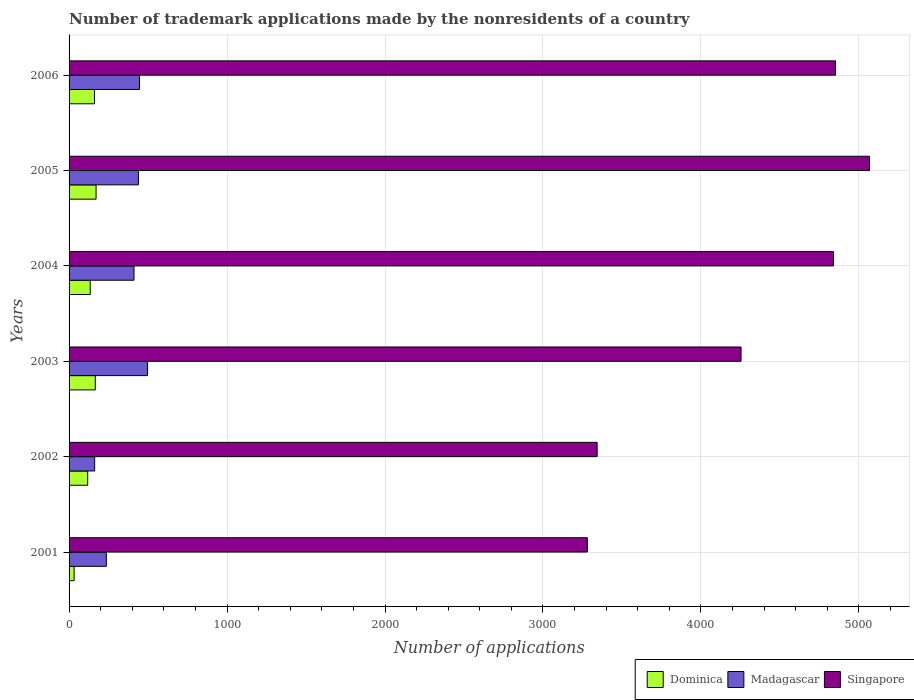Are the number of bars per tick equal to the number of legend labels?
Give a very brief answer. Yes. Are the number of bars on each tick of the Y-axis equal?
Offer a terse response. Yes. How many bars are there on the 6th tick from the bottom?
Make the answer very short. 3. What is the label of the 1st group of bars from the top?
Give a very brief answer. 2006. In how many cases, is the number of bars for a given year not equal to the number of legend labels?
Offer a very short reply. 0. What is the number of trademark applications made by the nonresidents in Singapore in 2004?
Keep it short and to the point. 4839. Across all years, what is the maximum number of trademark applications made by the nonresidents in Singapore?
Offer a terse response. 5067. Across all years, what is the minimum number of trademark applications made by the nonresidents in Madagascar?
Ensure brevity in your answer.  162. What is the total number of trademark applications made by the nonresidents in Madagascar in the graph?
Ensure brevity in your answer.  2191. What is the difference between the number of trademark applications made by the nonresidents in Madagascar in 2002 and that in 2005?
Your answer should be compact. -277. What is the difference between the number of trademark applications made by the nonresidents in Madagascar in 2006 and the number of trademark applications made by the nonresidents in Singapore in 2003?
Provide a short and direct response. -3808. What is the average number of trademark applications made by the nonresidents in Singapore per year?
Offer a very short reply. 4272.67. In the year 2005, what is the difference between the number of trademark applications made by the nonresidents in Dominica and number of trademark applications made by the nonresidents in Madagascar?
Your answer should be compact. -268. What is the ratio of the number of trademark applications made by the nonresidents in Dominica in 2002 to that in 2006?
Ensure brevity in your answer.  0.73. Is the difference between the number of trademark applications made by the nonresidents in Dominica in 2002 and 2003 greater than the difference between the number of trademark applications made by the nonresidents in Madagascar in 2002 and 2003?
Your answer should be compact. Yes. What is the difference between the highest and the lowest number of trademark applications made by the nonresidents in Madagascar?
Make the answer very short. 335. Is the sum of the number of trademark applications made by the nonresidents in Dominica in 2003 and 2006 greater than the maximum number of trademark applications made by the nonresidents in Madagascar across all years?
Provide a short and direct response. No. What does the 3rd bar from the top in 2002 represents?
Your answer should be very brief. Dominica. What does the 1st bar from the bottom in 2006 represents?
Your answer should be very brief. Dominica. Is it the case that in every year, the sum of the number of trademark applications made by the nonresidents in Madagascar and number of trademark applications made by the nonresidents in Dominica is greater than the number of trademark applications made by the nonresidents in Singapore?
Offer a very short reply. No. How many bars are there?
Your answer should be compact. 18. Are all the bars in the graph horizontal?
Offer a very short reply. Yes. Are the values on the major ticks of X-axis written in scientific E-notation?
Make the answer very short. No. Does the graph contain grids?
Give a very brief answer. Yes. Where does the legend appear in the graph?
Keep it short and to the point. Bottom right. How many legend labels are there?
Make the answer very short. 3. How are the legend labels stacked?
Keep it short and to the point. Horizontal. What is the title of the graph?
Keep it short and to the point. Number of trademark applications made by the nonresidents of a country. What is the label or title of the X-axis?
Keep it short and to the point. Number of applications. What is the label or title of the Y-axis?
Offer a terse response. Years. What is the Number of applications of Madagascar in 2001?
Your response must be concise. 236. What is the Number of applications in Singapore in 2001?
Offer a terse response. 3281. What is the Number of applications of Dominica in 2002?
Your answer should be very brief. 118. What is the Number of applications of Madagascar in 2002?
Your answer should be very brief. 162. What is the Number of applications in Singapore in 2002?
Your answer should be very brief. 3343. What is the Number of applications of Dominica in 2003?
Your answer should be compact. 166. What is the Number of applications of Madagascar in 2003?
Offer a very short reply. 497. What is the Number of applications of Singapore in 2003?
Your answer should be very brief. 4254. What is the Number of applications in Dominica in 2004?
Offer a terse response. 134. What is the Number of applications in Madagascar in 2004?
Offer a terse response. 411. What is the Number of applications in Singapore in 2004?
Offer a very short reply. 4839. What is the Number of applications of Dominica in 2005?
Offer a very short reply. 171. What is the Number of applications in Madagascar in 2005?
Your response must be concise. 439. What is the Number of applications in Singapore in 2005?
Provide a succinct answer. 5067. What is the Number of applications in Dominica in 2006?
Offer a terse response. 161. What is the Number of applications of Madagascar in 2006?
Offer a terse response. 446. What is the Number of applications in Singapore in 2006?
Offer a very short reply. 4852. Across all years, what is the maximum Number of applications of Dominica?
Your answer should be very brief. 171. Across all years, what is the maximum Number of applications in Madagascar?
Make the answer very short. 497. Across all years, what is the maximum Number of applications of Singapore?
Give a very brief answer. 5067. Across all years, what is the minimum Number of applications in Dominica?
Give a very brief answer. 32. Across all years, what is the minimum Number of applications of Madagascar?
Keep it short and to the point. 162. Across all years, what is the minimum Number of applications in Singapore?
Ensure brevity in your answer.  3281. What is the total Number of applications of Dominica in the graph?
Give a very brief answer. 782. What is the total Number of applications in Madagascar in the graph?
Give a very brief answer. 2191. What is the total Number of applications of Singapore in the graph?
Offer a terse response. 2.56e+04. What is the difference between the Number of applications in Dominica in 2001 and that in 2002?
Your answer should be very brief. -86. What is the difference between the Number of applications in Singapore in 2001 and that in 2002?
Your answer should be very brief. -62. What is the difference between the Number of applications of Dominica in 2001 and that in 2003?
Your answer should be compact. -134. What is the difference between the Number of applications of Madagascar in 2001 and that in 2003?
Keep it short and to the point. -261. What is the difference between the Number of applications of Singapore in 2001 and that in 2003?
Your answer should be compact. -973. What is the difference between the Number of applications of Dominica in 2001 and that in 2004?
Provide a short and direct response. -102. What is the difference between the Number of applications of Madagascar in 2001 and that in 2004?
Your answer should be very brief. -175. What is the difference between the Number of applications in Singapore in 2001 and that in 2004?
Offer a very short reply. -1558. What is the difference between the Number of applications in Dominica in 2001 and that in 2005?
Ensure brevity in your answer.  -139. What is the difference between the Number of applications of Madagascar in 2001 and that in 2005?
Keep it short and to the point. -203. What is the difference between the Number of applications of Singapore in 2001 and that in 2005?
Make the answer very short. -1786. What is the difference between the Number of applications of Dominica in 2001 and that in 2006?
Make the answer very short. -129. What is the difference between the Number of applications of Madagascar in 2001 and that in 2006?
Your response must be concise. -210. What is the difference between the Number of applications of Singapore in 2001 and that in 2006?
Your answer should be compact. -1571. What is the difference between the Number of applications of Dominica in 2002 and that in 2003?
Offer a very short reply. -48. What is the difference between the Number of applications of Madagascar in 2002 and that in 2003?
Offer a terse response. -335. What is the difference between the Number of applications of Singapore in 2002 and that in 2003?
Your answer should be compact. -911. What is the difference between the Number of applications in Madagascar in 2002 and that in 2004?
Give a very brief answer. -249. What is the difference between the Number of applications in Singapore in 2002 and that in 2004?
Keep it short and to the point. -1496. What is the difference between the Number of applications in Dominica in 2002 and that in 2005?
Your response must be concise. -53. What is the difference between the Number of applications of Madagascar in 2002 and that in 2005?
Give a very brief answer. -277. What is the difference between the Number of applications of Singapore in 2002 and that in 2005?
Ensure brevity in your answer.  -1724. What is the difference between the Number of applications in Dominica in 2002 and that in 2006?
Give a very brief answer. -43. What is the difference between the Number of applications of Madagascar in 2002 and that in 2006?
Your answer should be very brief. -284. What is the difference between the Number of applications in Singapore in 2002 and that in 2006?
Give a very brief answer. -1509. What is the difference between the Number of applications of Singapore in 2003 and that in 2004?
Make the answer very short. -585. What is the difference between the Number of applications of Dominica in 2003 and that in 2005?
Keep it short and to the point. -5. What is the difference between the Number of applications of Singapore in 2003 and that in 2005?
Provide a short and direct response. -813. What is the difference between the Number of applications in Madagascar in 2003 and that in 2006?
Provide a succinct answer. 51. What is the difference between the Number of applications in Singapore in 2003 and that in 2006?
Provide a short and direct response. -598. What is the difference between the Number of applications in Dominica in 2004 and that in 2005?
Provide a short and direct response. -37. What is the difference between the Number of applications of Madagascar in 2004 and that in 2005?
Keep it short and to the point. -28. What is the difference between the Number of applications of Singapore in 2004 and that in 2005?
Provide a succinct answer. -228. What is the difference between the Number of applications in Dominica in 2004 and that in 2006?
Keep it short and to the point. -27. What is the difference between the Number of applications of Madagascar in 2004 and that in 2006?
Provide a short and direct response. -35. What is the difference between the Number of applications of Dominica in 2005 and that in 2006?
Offer a very short reply. 10. What is the difference between the Number of applications of Singapore in 2005 and that in 2006?
Provide a short and direct response. 215. What is the difference between the Number of applications of Dominica in 2001 and the Number of applications of Madagascar in 2002?
Offer a terse response. -130. What is the difference between the Number of applications of Dominica in 2001 and the Number of applications of Singapore in 2002?
Your answer should be compact. -3311. What is the difference between the Number of applications in Madagascar in 2001 and the Number of applications in Singapore in 2002?
Offer a terse response. -3107. What is the difference between the Number of applications of Dominica in 2001 and the Number of applications of Madagascar in 2003?
Your response must be concise. -465. What is the difference between the Number of applications of Dominica in 2001 and the Number of applications of Singapore in 2003?
Offer a very short reply. -4222. What is the difference between the Number of applications of Madagascar in 2001 and the Number of applications of Singapore in 2003?
Offer a very short reply. -4018. What is the difference between the Number of applications of Dominica in 2001 and the Number of applications of Madagascar in 2004?
Make the answer very short. -379. What is the difference between the Number of applications in Dominica in 2001 and the Number of applications in Singapore in 2004?
Ensure brevity in your answer.  -4807. What is the difference between the Number of applications in Madagascar in 2001 and the Number of applications in Singapore in 2004?
Make the answer very short. -4603. What is the difference between the Number of applications in Dominica in 2001 and the Number of applications in Madagascar in 2005?
Make the answer very short. -407. What is the difference between the Number of applications of Dominica in 2001 and the Number of applications of Singapore in 2005?
Give a very brief answer. -5035. What is the difference between the Number of applications in Madagascar in 2001 and the Number of applications in Singapore in 2005?
Your answer should be compact. -4831. What is the difference between the Number of applications of Dominica in 2001 and the Number of applications of Madagascar in 2006?
Ensure brevity in your answer.  -414. What is the difference between the Number of applications in Dominica in 2001 and the Number of applications in Singapore in 2006?
Your answer should be compact. -4820. What is the difference between the Number of applications of Madagascar in 2001 and the Number of applications of Singapore in 2006?
Offer a terse response. -4616. What is the difference between the Number of applications of Dominica in 2002 and the Number of applications of Madagascar in 2003?
Make the answer very short. -379. What is the difference between the Number of applications in Dominica in 2002 and the Number of applications in Singapore in 2003?
Offer a terse response. -4136. What is the difference between the Number of applications of Madagascar in 2002 and the Number of applications of Singapore in 2003?
Make the answer very short. -4092. What is the difference between the Number of applications in Dominica in 2002 and the Number of applications in Madagascar in 2004?
Your answer should be very brief. -293. What is the difference between the Number of applications in Dominica in 2002 and the Number of applications in Singapore in 2004?
Your response must be concise. -4721. What is the difference between the Number of applications in Madagascar in 2002 and the Number of applications in Singapore in 2004?
Keep it short and to the point. -4677. What is the difference between the Number of applications of Dominica in 2002 and the Number of applications of Madagascar in 2005?
Offer a terse response. -321. What is the difference between the Number of applications in Dominica in 2002 and the Number of applications in Singapore in 2005?
Provide a short and direct response. -4949. What is the difference between the Number of applications of Madagascar in 2002 and the Number of applications of Singapore in 2005?
Offer a very short reply. -4905. What is the difference between the Number of applications in Dominica in 2002 and the Number of applications in Madagascar in 2006?
Keep it short and to the point. -328. What is the difference between the Number of applications of Dominica in 2002 and the Number of applications of Singapore in 2006?
Give a very brief answer. -4734. What is the difference between the Number of applications of Madagascar in 2002 and the Number of applications of Singapore in 2006?
Ensure brevity in your answer.  -4690. What is the difference between the Number of applications in Dominica in 2003 and the Number of applications in Madagascar in 2004?
Provide a succinct answer. -245. What is the difference between the Number of applications of Dominica in 2003 and the Number of applications of Singapore in 2004?
Provide a short and direct response. -4673. What is the difference between the Number of applications in Madagascar in 2003 and the Number of applications in Singapore in 2004?
Provide a succinct answer. -4342. What is the difference between the Number of applications in Dominica in 2003 and the Number of applications in Madagascar in 2005?
Offer a very short reply. -273. What is the difference between the Number of applications of Dominica in 2003 and the Number of applications of Singapore in 2005?
Ensure brevity in your answer.  -4901. What is the difference between the Number of applications of Madagascar in 2003 and the Number of applications of Singapore in 2005?
Offer a terse response. -4570. What is the difference between the Number of applications in Dominica in 2003 and the Number of applications in Madagascar in 2006?
Provide a short and direct response. -280. What is the difference between the Number of applications in Dominica in 2003 and the Number of applications in Singapore in 2006?
Provide a succinct answer. -4686. What is the difference between the Number of applications in Madagascar in 2003 and the Number of applications in Singapore in 2006?
Offer a terse response. -4355. What is the difference between the Number of applications in Dominica in 2004 and the Number of applications in Madagascar in 2005?
Offer a very short reply. -305. What is the difference between the Number of applications of Dominica in 2004 and the Number of applications of Singapore in 2005?
Offer a very short reply. -4933. What is the difference between the Number of applications in Madagascar in 2004 and the Number of applications in Singapore in 2005?
Your answer should be compact. -4656. What is the difference between the Number of applications of Dominica in 2004 and the Number of applications of Madagascar in 2006?
Offer a terse response. -312. What is the difference between the Number of applications in Dominica in 2004 and the Number of applications in Singapore in 2006?
Keep it short and to the point. -4718. What is the difference between the Number of applications in Madagascar in 2004 and the Number of applications in Singapore in 2006?
Offer a very short reply. -4441. What is the difference between the Number of applications of Dominica in 2005 and the Number of applications of Madagascar in 2006?
Offer a terse response. -275. What is the difference between the Number of applications in Dominica in 2005 and the Number of applications in Singapore in 2006?
Your response must be concise. -4681. What is the difference between the Number of applications in Madagascar in 2005 and the Number of applications in Singapore in 2006?
Your response must be concise. -4413. What is the average Number of applications in Dominica per year?
Your answer should be compact. 130.33. What is the average Number of applications of Madagascar per year?
Your answer should be very brief. 365.17. What is the average Number of applications of Singapore per year?
Provide a short and direct response. 4272.67. In the year 2001, what is the difference between the Number of applications of Dominica and Number of applications of Madagascar?
Give a very brief answer. -204. In the year 2001, what is the difference between the Number of applications in Dominica and Number of applications in Singapore?
Your response must be concise. -3249. In the year 2001, what is the difference between the Number of applications of Madagascar and Number of applications of Singapore?
Offer a very short reply. -3045. In the year 2002, what is the difference between the Number of applications in Dominica and Number of applications in Madagascar?
Offer a terse response. -44. In the year 2002, what is the difference between the Number of applications of Dominica and Number of applications of Singapore?
Your response must be concise. -3225. In the year 2002, what is the difference between the Number of applications of Madagascar and Number of applications of Singapore?
Make the answer very short. -3181. In the year 2003, what is the difference between the Number of applications of Dominica and Number of applications of Madagascar?
Provide a succinct answer. -331. In the year 2003, what is the difference between the Number of applications in Dominica and Number of applications in Singapore?
Keep it short and to the point. -4088. In the year 2003, what is the difference between the Number of applications of Madagascar and Number of applications of Singapore?
Provide a succinct answer. -3757. In the year 2004, what is the difference between the Number of applications of Dominica and Number of applications of Madagascar?
Offer a very short reply. -277. In the year 2004, what is the difference between the Number of applications of Dominica and Number of applications of Singapore?
Offer a very short reply. -4705. In the year 2004, what is the difference between the Number of applications of Madagascar and Number of applications of Singapore?
Your answer should be very brief. -4428. In the year 2005, what is the difference between the Number of applications in Dominica and Number of applications in Madagascar?
Ensure brevity in your answer.  -268. In the year 2005, what is the difference between the Number of applications in Dominica and Number of applications in Singapore?
Provide a short and direct response. -4896. In the year 2005, what is the difference between the Number of applications in Madagascar and Number of applications in Singapore?
Provide a succinct answer. -4628. In the year 2006, what is the difference between the Number of applications of Dominica and Number of applications of Madagascar?
Provide a succinct answer. -285. In the year 2006, what is the difference between the Number of applications in Dominica and Number of applications in Singapore?
Your answer should be compact. -4691. In the year 2006, what is the difference between the Number of applications in Madagascar and Number of applications in Singapore?
Your answer should be very brief. -4406. What is the ratio of the Number of applications in Dominica in 2001 to that in 2002?
Make the answer very short. 0.27. What is the ratio of the Number of applications in Madagascar in 2001 to that in 2002?
Your answer should be compact. 1.46. What is the ratio of the Number of applications in Singapore in 2001 to that in 2002?
Keep it short and to the point. 0.98. What is the ratio of the Number of applications of Dominica in 2001 to that in 2003?
Your answer should be very brief. 0.19. What is the ratio of the Number of applications in Madagascar in 2001 to that in 2003?
Your answer should be very brief. 0.47. What is the ratio of the Number of applications in Singapore in 2001 to that in 2003?
Provide a short and direct response. 0.77. What is the ratio of the Number of applications of Dominica in 2001 to that in 2004?
Ensure brevity in your answer.  0.24. What is the ratio of the Number of applications in Madagascar in 2001 to that in 2004?
Your answer should be very brief. 0.57. What is the ratio of the Number of applications in Singapore in 2001 to that in 2004?
Ensure brevity in your answer.  0.68. What is the ratio of the Number of applications in Dominica in 2001 to that in 2005?
Make the answer very short. 0.19. What is the ratio of the Number of applications of Madagascar in 2001 to that in 2005?
Provide a short and direct response. 0.54. What is the ratio of the Number of applications in Singapore in 2001 to that in 2005?
Provide a short and direct response. 0.65. What is the ratio of the Number of applications of Dominica in 2001 to that in 2006?
Provide a succinct answer. 0.2. What is the ratio of the Number of applications of Madagascar in 2001 to that in 2006?
Your answer should be compact. 0.53. What is the ratio of the Number of applications in Singapore in 2001 to that in 2006?
Offer a very short reply. 0.68. What is the ratio of the Number of applications in Dominica in 2002 to that in 2003?
Keep it short and to the point. 0.71. What is the ratio of the Number of applications in Madagascar in 2002 to that in 2003?
Ensure brevity in your answer.  0.33. What is the ratio of the Number of applications in Singapore in 2002 to that in 2003?
Make the answer very short. 0.79. What is the ratio of the Number of applications in Dominica in 2002 to that in 2004?
Your answer should be very brief. 0.88. What is the ratio of the Number of applications of Madagascar in 2002 to that in 2004?
Ensure brevity in your answer.  0.39. What is the ratio of the Number of applications of Singapore in 2002 to that in 2004?
Your answer should be very brief. 0.69. What is the ratio of the Number of applications in Dominica in 2002 to that in 2005?
Keep it short and to the point. 0.69. What is the ratio of the Number of applications in Madagascar in 2002 to that in 2005?
Offer a terse response. 0.37. What is the ratio of the Number of applications in Singapore in 2002 to that in 2005?
Make the answer very short. 0.66. What is the ratio of the Number of applications in Dominica in 2002 to that in 2006?
Your response must be concise. 0.73. What is the ratio of the Number of applications in Madagascar in 2002 to that in 2006?
Your answer should be compact. 0.36. What is the ratio of the Number of applications in Singapore in 2002 to that in 2006?
Keep it short and to the point. 0.69. What is the ratio of the Number of applications of Dominica in 2003 to that in 2004?
Provide a succinct answer. 1.24. What is the ratio of the Number of applications of Madagascar in 2003 to that in 2004?
Your answer should be very brief. 1.21. What is the ratio of the Number of applications in Singapore in 2003 to that in 2004?
Your response must be concise. 0.88. What is the ratio of the Number of applications of Dominica in 2003 to that in 2005?
Provide a succinct answer. 0.97. What is the ratio of the Number of applications in Madagascar in 2003 to that in 2005?
Offer a very short reply. 1.13. What is the ratio of the Number of applications of Singapore in 2003 to that in 2005?
Ensure brevity in your answer.  0.84. What is the ratio of the Number of applications of Dominica in 2003 to that in 2006?
Offer a very short reply. 1.03. What is the ratio of the Number of applications in Madagascar in 2003 to that in 2006?
Your response must be concise. 1.11. What is the ratio of the Number of applications in Singapore in 2003 to that in 2006?
Give a very brief answer. 0.88. What is the ratio of the Number of applications in Dominica in 2004 to that in 2005?
Your answer should be compact. 0.78. What is the ratio of the Number of applications in Madagascar in 2004 to that in 2005?
Provide a short and direct response. 0.94. What is the ratio of the Number of applications in Singapore in 2004 to that in 2005?
Give a very brief answer. 0.95. What is the ratio of the Number of applications of Dominica in 2004 to that in 2006?
Offer a terse response. 0.83. What is the ratio of the Number of applications of Madagascar in 2004 to that in 2006?
Keep it short and to the point. 0.92. What is the ratio of the Number of applications of Dominica in 2005 to that in 2006?
Offer a very short reply. 1.06. What is the ratio of the Number of applications of Madagascar in 2005 to that in 2006?
Offer a terse response. 0.98. What is the ratio of the Number of applications of Singapore in 2005 to that in 2006?
Make the answer very short. 1.04. What is the difference between the highest and the second highest Number of applications of Dominica?
Your response must be concise. 5. What is the difference between the highest and the second highest Number of applications of Madagascar?
Provide a short and direct response. 51. What is the difference between the highest and the second highest Number of applications in Singapore?
Offer a very short reply. 215. What is the difference between the highest and the lowest Number of applications of Dominica?
Offer a very short reply. 139. What is the difference between the highest and the lowest Number of applications in Madagascar?
Give a very brief answer. 335. What is the difference between the highest and the lowest Number of applications in Singapore?
Ensure brevity in your answer.  1786. 